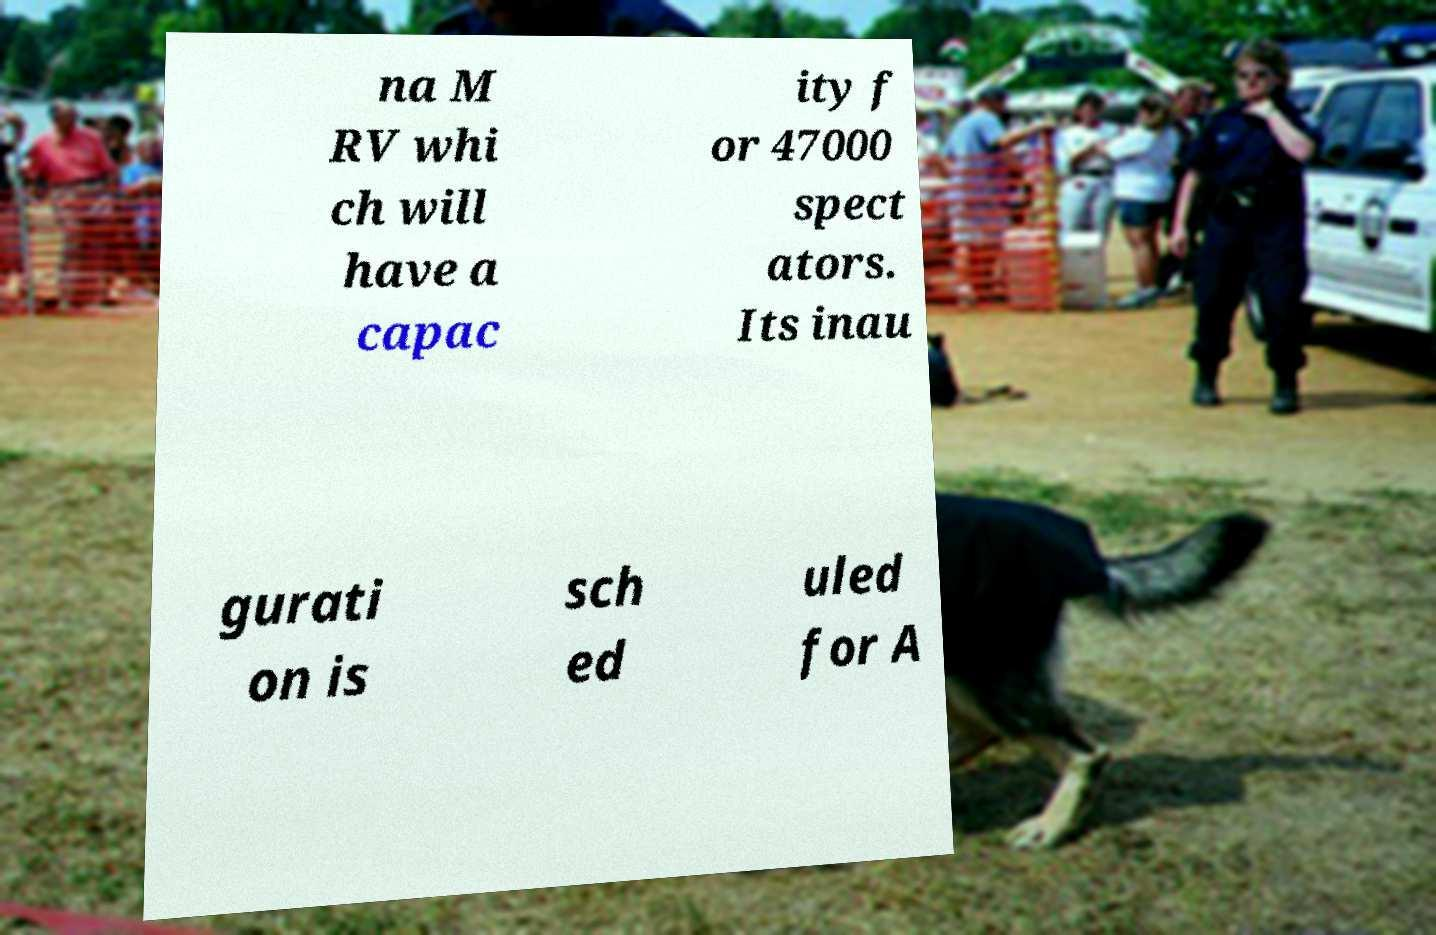Can you read and provide the text displayed in the image?This photo seems to have some interesting text. Can you extract and type it out for me? na M RV whi ch will have a capac ity f or 47000 spect ators. Its inau gurati on is sch ed uled for A 